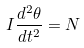<formula> <loc_0><loc_0><loc_500><loc_500>I \frac { d ^ { 2 } \theta } { d t ^ { 2 } } = N</formula> 